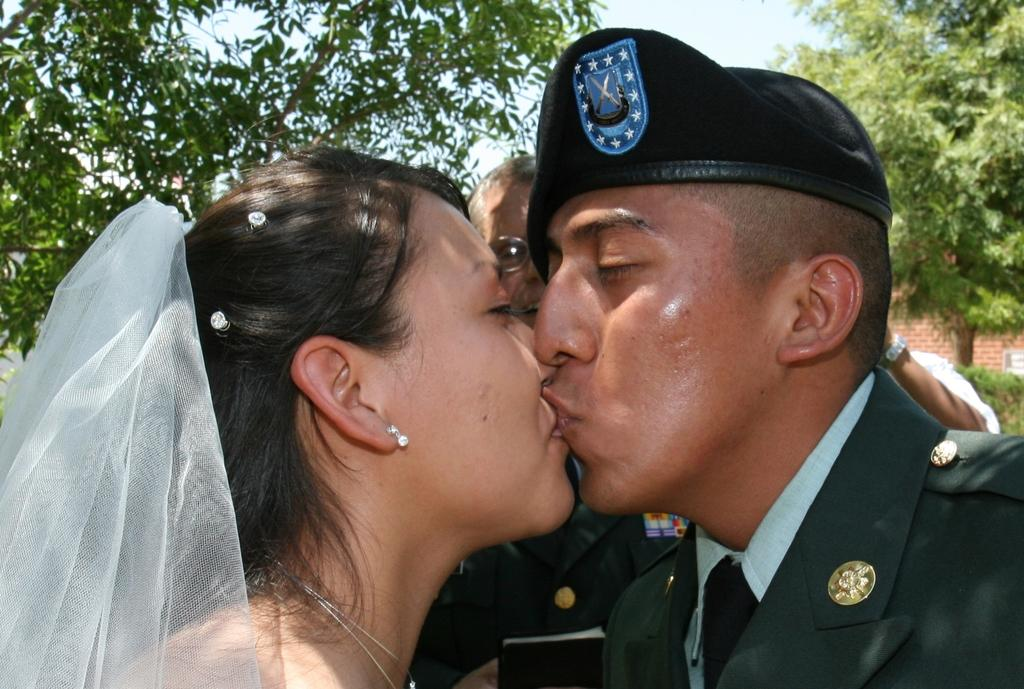Who are the two people in the image? There is a man and a woman in the image. What are the man and woman doing in the image? The man and woman are kissing each other. Can you describe the background of the image? There is a man in the background, treats are visible, there is a brick wall, and the sky is visible. What type of noise can be heard coming from the seashore in the image? There is no seashore present in the image, so it's not possible to determine what, if any, noise might be heard. 